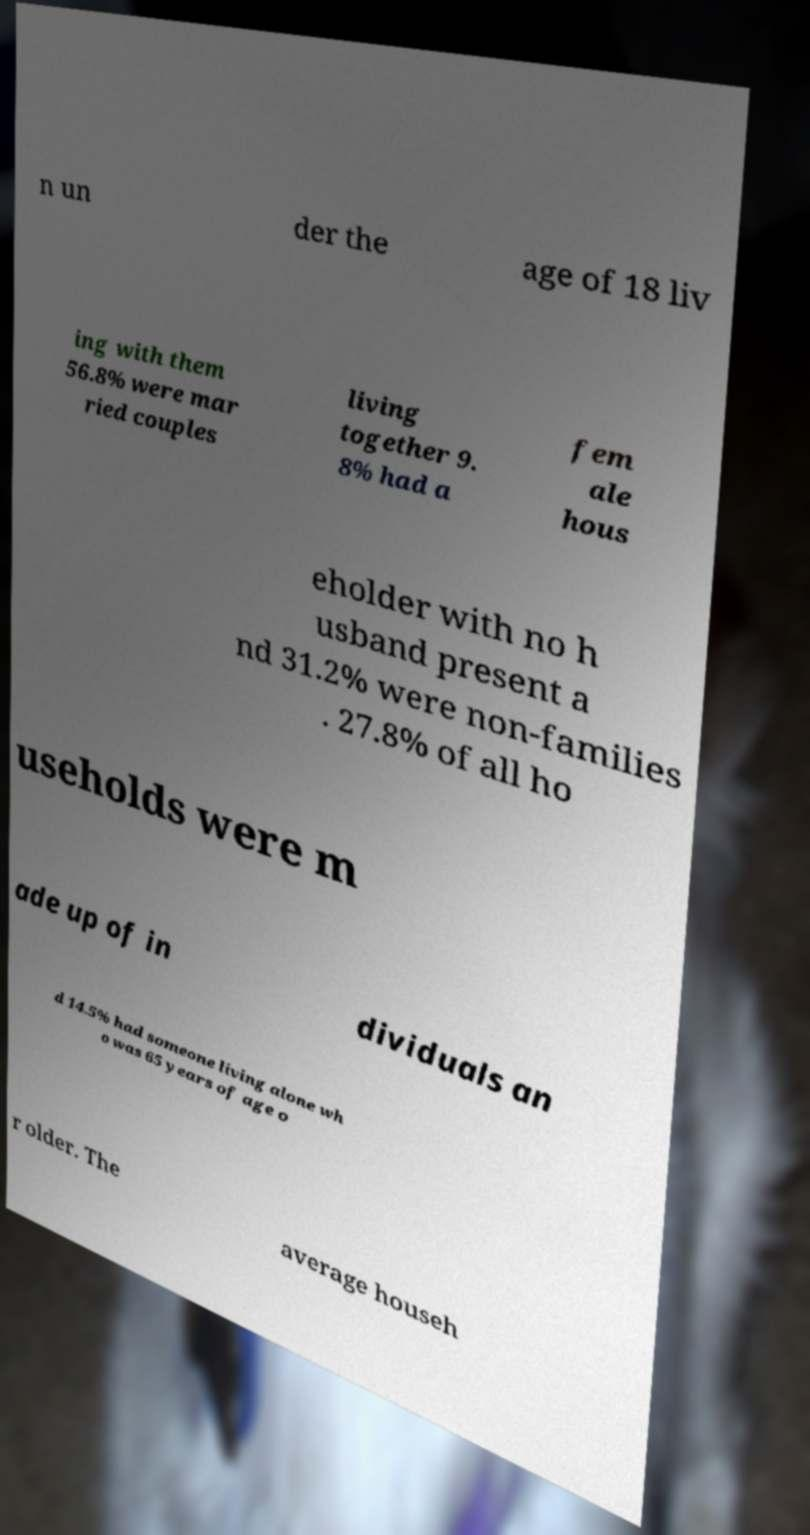Please read and relay the text visible in this image. What does it say? n un der the age of 18 liv ing with them 56.8% were mar ried couples living together 9. 8% had a fem ale hous eholder with no h usband present a nd 31.2% were non-families . 27.8% of all ho useholds were m ade up of in dividuals an d 14.5% had someone living alone wh o was 65 years of age o r older. The average househ 